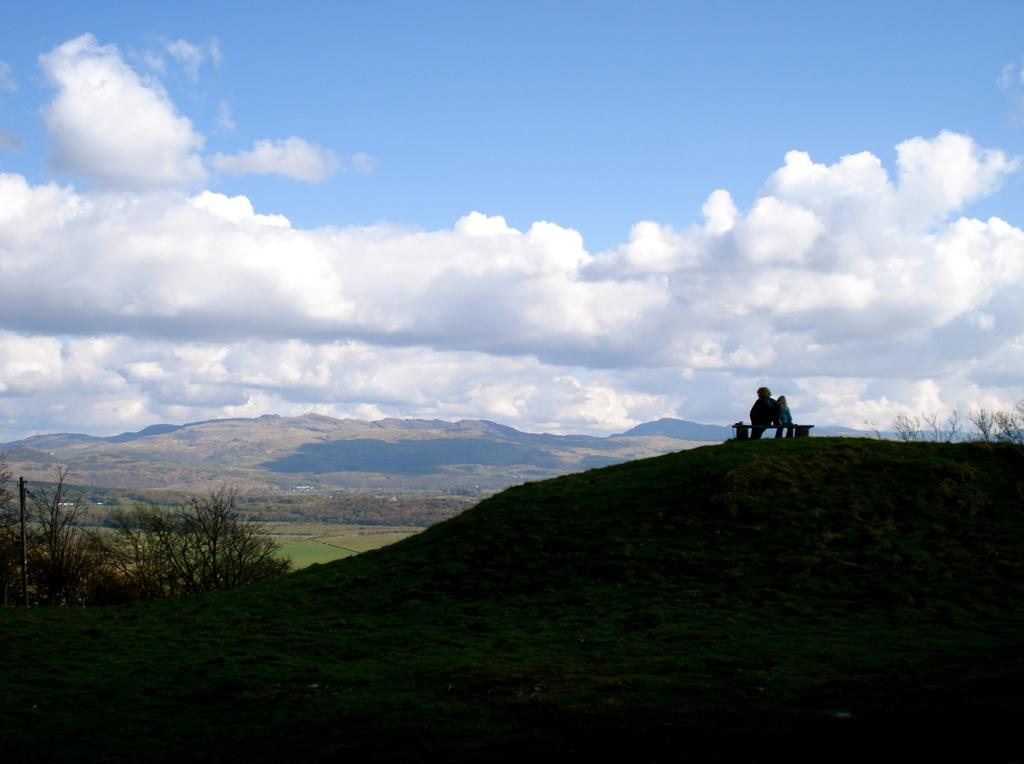What type of vegetation can be seen in the image? There are plants and grass in the image. What natural landmarks are visible in the image? There are mountains in the image. Are there any human figures in the image? Yes, there are people in the image. What is the condition of the sky in the background of the image? The sky appears to be cloudy in the background of the image. Can you see any hands holding a basket filled with oranges in the image? No, there are no hands, baskets, or oranges present in the image. 